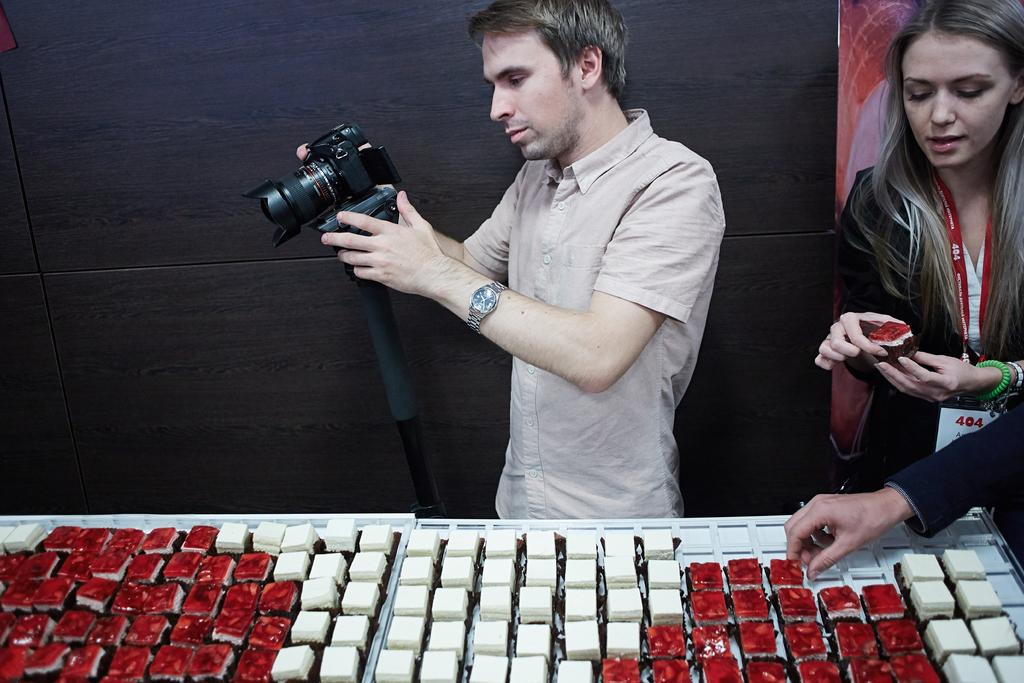Who are the people in the image? There is a man and a woman in the image. What is the man holding in the image? The man is holding a camera. What can be seen on the table in the image? There are objects on a table in the image. What type of school can be seen in the image? There is no school present in the image. What kind of connection is the man making with the woman in the image? The image does not depict any specific connection between the man and the woman. 